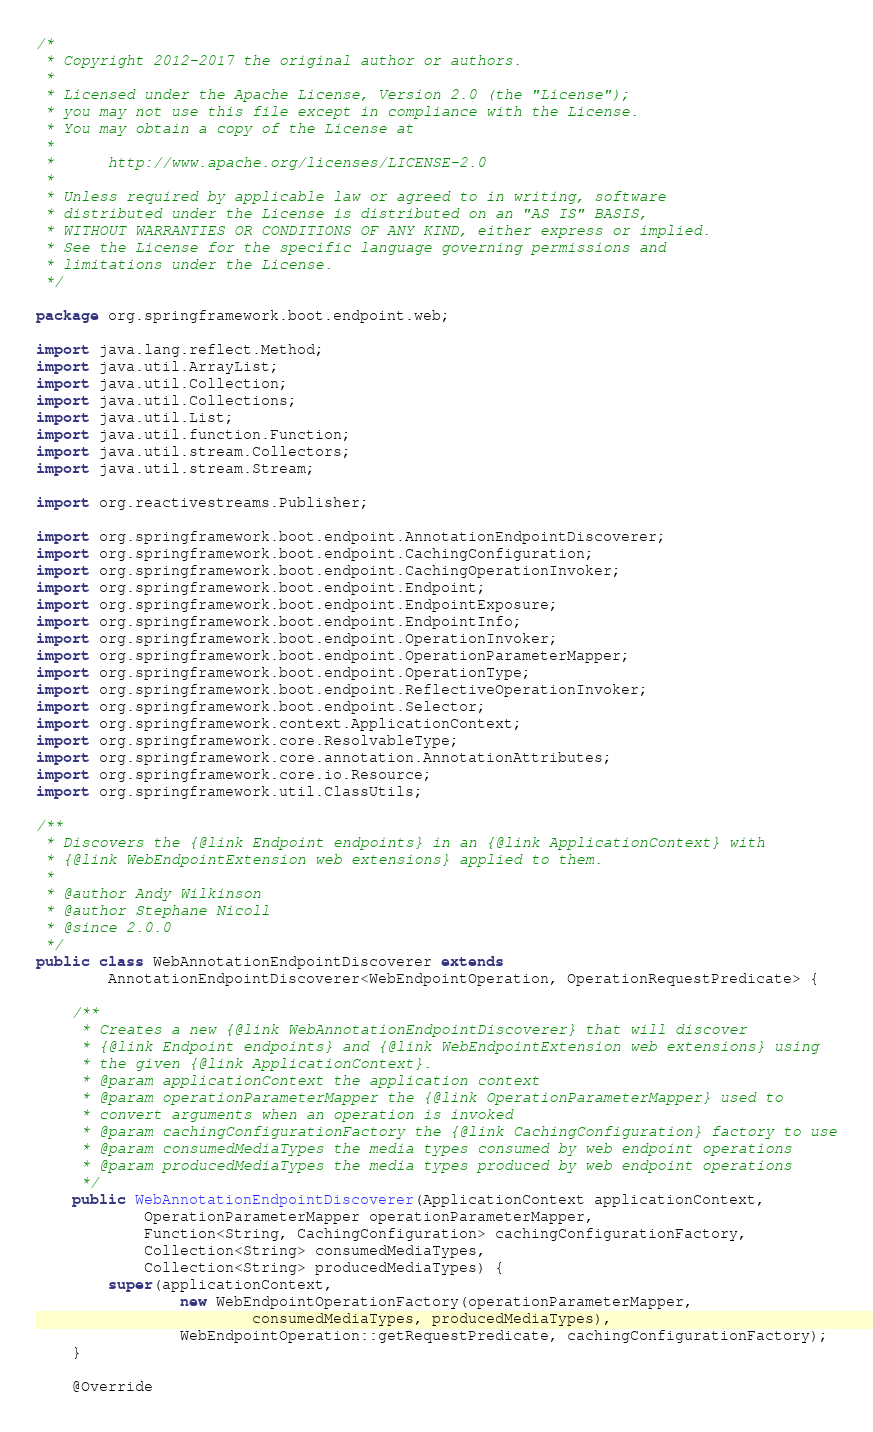Convert code to text. <code><loc_0><loc_0><loc_500><loc_500><_Java_>/*
 * Copyright 2012-2017 the original author or authors.
 *
 * Licensed under the Apache License, Version 2.0 (the "License");
 * you may not use this file except in compliance with the License.
 * You may obtain a copy of the License at
 *
 *      http://www.apache.org/licenses/LICENSE-2.0
 *
 * Unless required by applicable law or agreed to in writing, software
 * distributed under the License is distributed on an "AS IS" BASIS,
 * WITHOUT WARRANTIES OR CONDITIONS OF ANY KIND, either express or implied.
 * See the License for the specific language governing permissions and
 * limitations under the License.
 */

package org.springframework.boot.endpoint.web;

import java.lang.reflect.Method;
import java.util.ArrayList;
import java.util.Collection;
import java.util.Collections;
import java.util.List;
import java.util.function.Function;
import java.util.stream.Collectors;
import java.util.stream.Stream;

import org.reactivestreams.Publisher;

import org.springframework.boot.endpoint.AnnotationEndpointDiscoverer;
import org.springframework.boot.endpoint.CachingConfiguration;
import org.springframework.boot.endpoint.CachingOperationInvoker;
import org.springframework.boot.endpoint.Endpoint;
import org.springframework.boot.endpoint.EndpointExposure;
import org.springframework.boot.endpoint.EndpointInfo;
import org.springframework.boot.endpoint.OperationInvoker;
import org.springframework.boot.endpoint.OperationParameterMapper;
import org.springframework.boot.endpoint.OperationType;
import org.springframework.boot.endpoint.ReflectiveOperationInvoker;
import org.springframework.boot.endpoint.Selector;
import org.springframework.context.ApplicationContext;
import org.springframework.core.ResolvableType;
import org.springframework.core.annotation.AnnotationAttributes;
import org.springframework.core.io.Resource;
import org.springframework.util.ClassUtils;

/**
 * Discovers the {@link Endpoint endpoints} in an {@link ApplicationContext} with
 * {@link WebEndpointExtension web extensions} applied to them.
 *
 * @author Andy Wilkinson
 * @author Stephane Nicoll
 * @since 2.0.0
 */
public class WebAnnotationEndpointDiscoverer extends
		AnnotationEndpointDiscoverer<WebEndpointOperation, OperationRequestPredicate> {

	/**
	 * Creates a new {@link WebAnnotationEndpointDiscoverer} that will discover
	 * {@link Endpoint endpoints} and {@link WebEndpointExtension web extensions} using
	 * the given {@link ApplicationContext}.
	 * @param applicationContext the application context
	 * @param operationParameterMapper the {@link OperationParameterMapper} used to
	 * convert arguments when an operation is invoked
	 * @param cachingConfigurationFactory the {@link CachingConfiguration} factory to use
	 * @param consumedMediaTypes the media types consumed by web endpoint operations
	 * @param producedMediaTypes the media types produced by web endpoint operations
	 */
	public WebAnnotationEndpointDiscoverer(ApplicationContext applicationContext,
			OperationParameterMapper operationParameterMapper,
			Function<String, CachingConfiguration> cachingConfigurationFactory,
			Collection<String> consumedMediaTypes,
			Collection<String> producedMediaTypes) {
		super(applicationContext,
				new WebEndpointOperationFactory(operationParameterMapper,
						consumedMediaTypes, producedMediaTypes),
				WebEndpointOperation::getRequestPredicate, cachingConfigurationFactory);
	}

	@Override</code> 